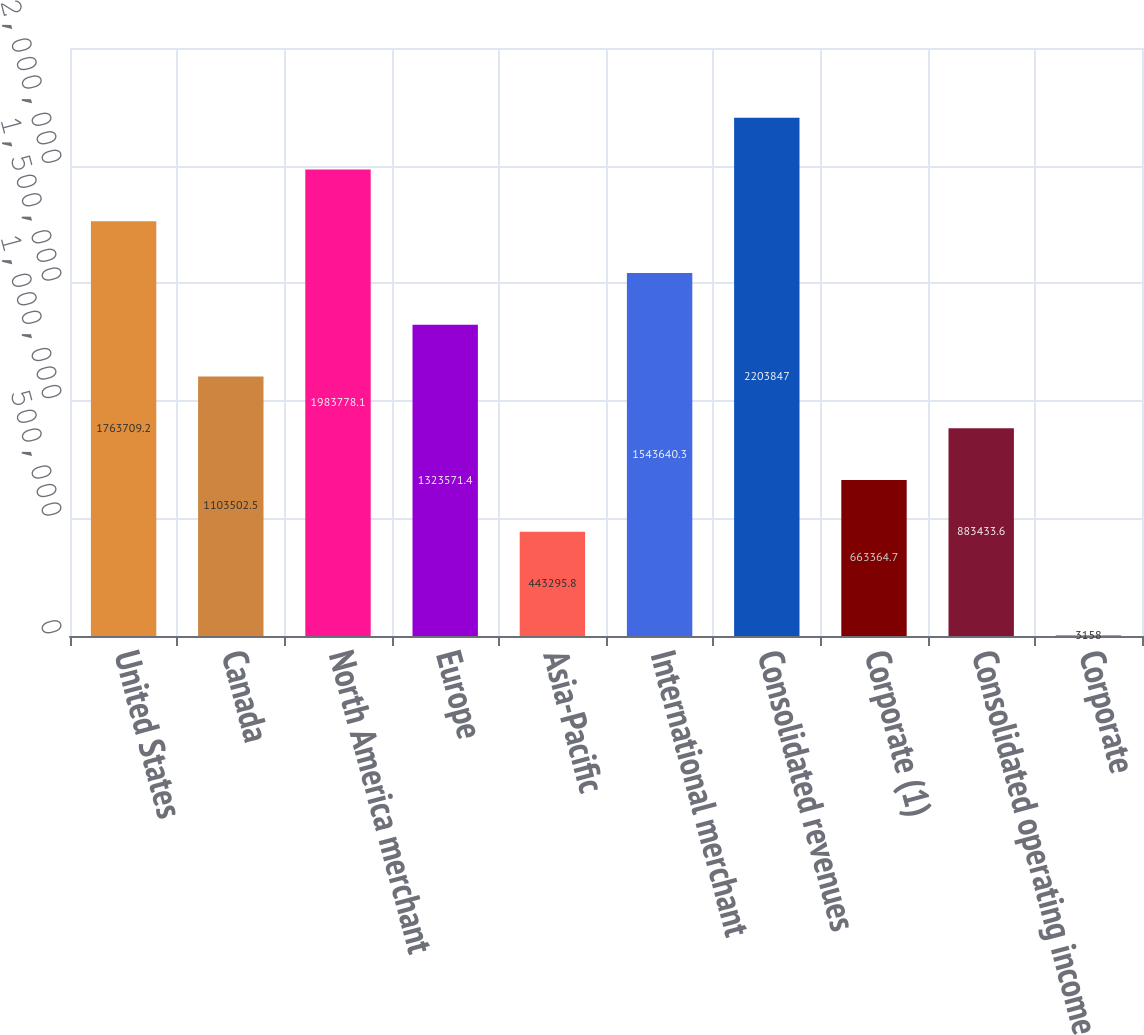<chart> <loc_0><loc_0><loc_500><loc_500><bar_chart><fcel>United States<fcel>Canada<fcel>North America merchant<fcel>Europe<fcel>Asia-Pacific<fcel>International merchant<fcel>Consolidated revenues<fcel>Corporate (1)<fcel>Consolidated operating income<fcel>Corporate<nl><fcel>1.76371e+06<fcel>1.1035e+06<fcel>1.98378e+06<fcel>1.32357e+06<fcel>443296<fcel>1.54364e+06<fcel>2.20385e+06<fcel>663365<fcel>883434<fcel>3158<nl></chart> 